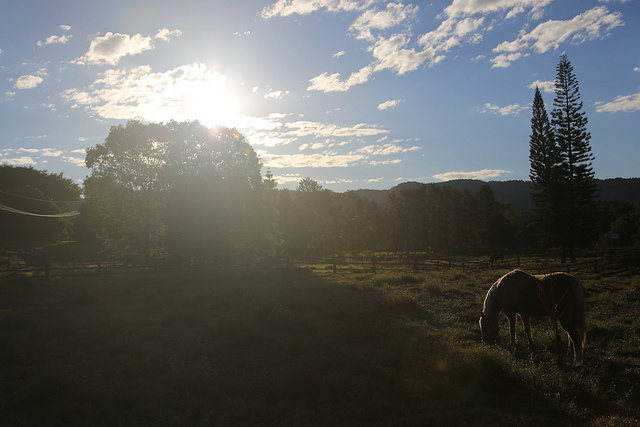Can you describe the weather in the image? The weather in the image seems clear and sunny. There are a few clouds in the sky, but they are sparse and do not indicate any immediate threat of rain. Does it look like it's been raining recently? It does not appear to have rained recently. The sunlight and shadows are strong and crisp, suggesting that the ground is dry, and the animals are enjoying a pleasant day. 